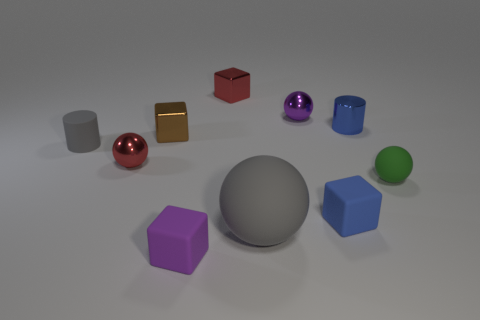Subtract all cylinders. How many objects are left? 8 Subtract 0 yellow balls. How many objects are left? 10 Subtract all cyan metal cubes. Subtract all blue rubber cubes. How many objects are left? 9 Add 4 gray cylinders. How many gray cylinders are left? 5 Add 5 tiny shiny things. How many tiny shiny things exist? 10 